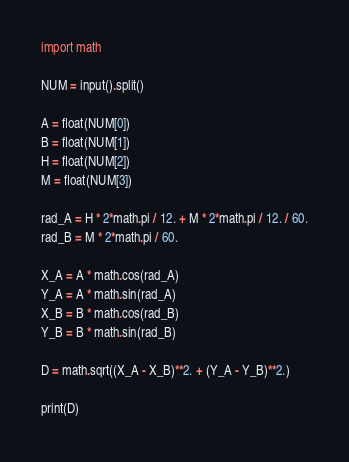Convert code to text. <code><loc_0><loc_0><loc_500><loc_500><_Python_>import math

NUM = input().split()

A = float(NUM[0])
B = float(NUM[1])
H = float(NUM[2])
M = float(NUM[3])

rad_A = H * 2*math.pi / 12. + M * 2*math.pi / 12. / 60.
rad_B = M * 2*math.pi / 60.

X_A = A * math.cos(rad_A)
Y_A = A * math.sin(rad_A)
X_B = B * math.cos(rad_B)
Y_B = B * math.sin(rad_B)

D = math.sqrt((X_A - X_B)**2. + (Y_A - Y_B)**2.)

print(D)</code> 